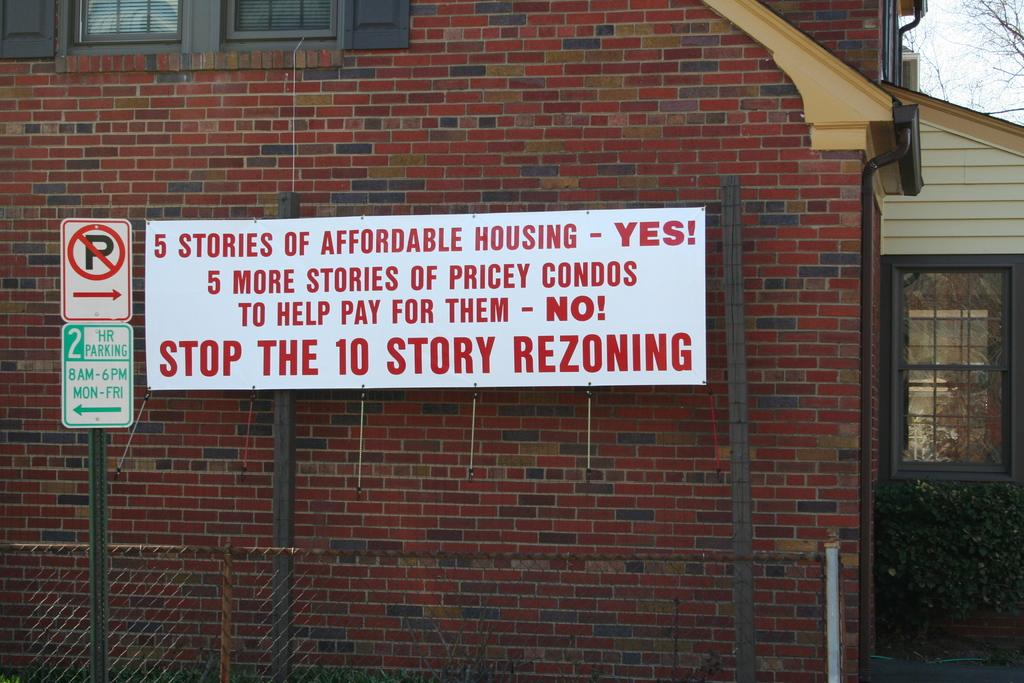What type of structure is visible in the image? There is a house in the image. What else can be seen on the board in the image? There is a board with text in the image. What type of sign is present in the image? There is a traffic sign board in the image. What type of vegetation is present in the image? There is a tree and a plant in the image. What type of quilt is draped over the house in the image? There is no quilt present in the image; it only features a house, a board with text, a traffic sign board, a tree, and a plant. 